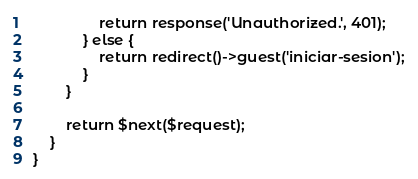Convert code to text. <code><loc_0><loc_0><loc_500><loc_500><_PHP_>                return response('Unauthorized.', 401);
            } else {
                return redirect()->guest('iniciar-sesion');
            }
        }

        return $next($request);
    }
}
</code> 